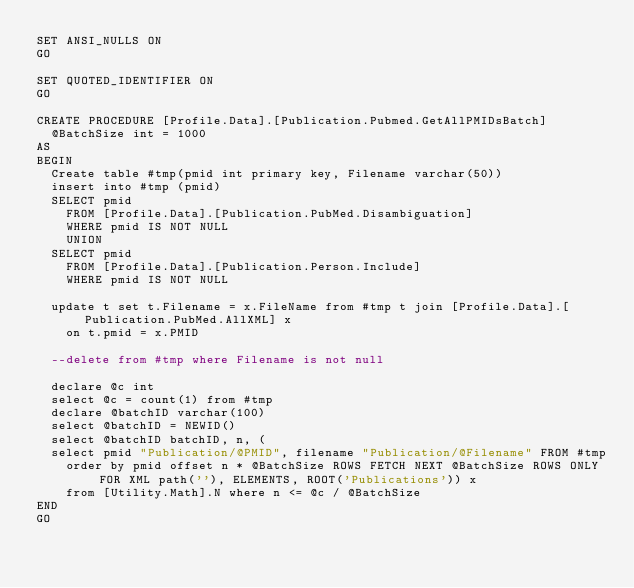<code> <loc_0><loc_0><loc_500><loc_500><_SQL_>SET ANSI_NULLS ON
GO

SET QUOTED_IDENTIFIER ON
GO

CREATE PROCEDURE [Profile.Data].[Publication.Pubmed.GetAllPMIDsBatch]
	@BatchSize int = 1000
AS
BEGIN
	Create table #tmp(pmid int primary key, Filename varchar(50))
	insert into #tmp (pmid)
	SELECT pmid
		FROM [Profile.Data].[Publication.PubMed.Disambiguation]
		WHERE pmid IS NOT NULL 
		UNION   
	SELECT pmid
		FROM [Profile.Data].[Publication.Person.Include]
		WHERE pmid IS NOT NULL 

	update t set t.Filename = x.FileName from #tmp t join [Profile.Data].[Publication.PubMed.AllXML] x 
		on t.pmid = x.PMID

	--delete from #tmp where Filename is not null

	declare @c int
	select @c = count(1) from #tmp
	declare @batchID varchar(100)
	select @batchID = NEWID()
	select @batchID batchID, n, (
	select pmid "Publication/@PMID", filename "Publication/@Filename" FROM #tmp 
		order by pmid offset n * @BatchSize ROWS FETCH NEXT @BatchSize ROWS ONLY FOR XML path(''), ELEMENTS, ROOT('Publications')) x
		from [Utility.Math].N where n <= @c / @BatchSize
END
GO
</code> 